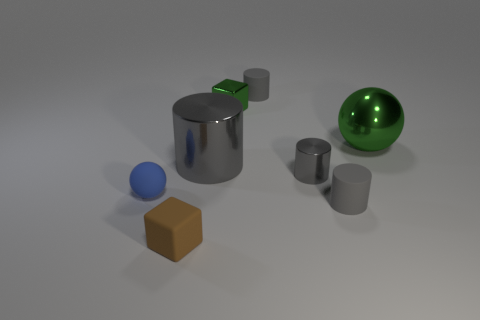Subtract all gray cylinders. How many were subtracted if there are2gray cylinders left? 2 Subtract 1 cylinders. How many cylinders are left? 3 Subtract all blue cylinders. Subtract all brown spheres. How many cylinders are left? 4 Add 2 red cylinders. How many objects exist? 10 Subtract all spheres. How many objects are left? 6 Add 5 small rubber cylinders. How many small rubber cylinders are left? 7 Add 1 green metal spheres. How many green metal spheres exist? 2 Subtract 0 cyan spheres. How many objects are left? 8 Subtract all tiny gray blocks. Subtract all green metal things. How many objects are left? 6 